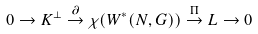<formula> <loc_0><loc_0><loc_500><loc_500>0 \rightarrow K ^ { \bot } \overset { \partial } { \rightarrow } \chi ( W ^ { * } ( N , G ) ) \overset { \Pi } { \rightarrow } L \rightarrow 0</formula> 